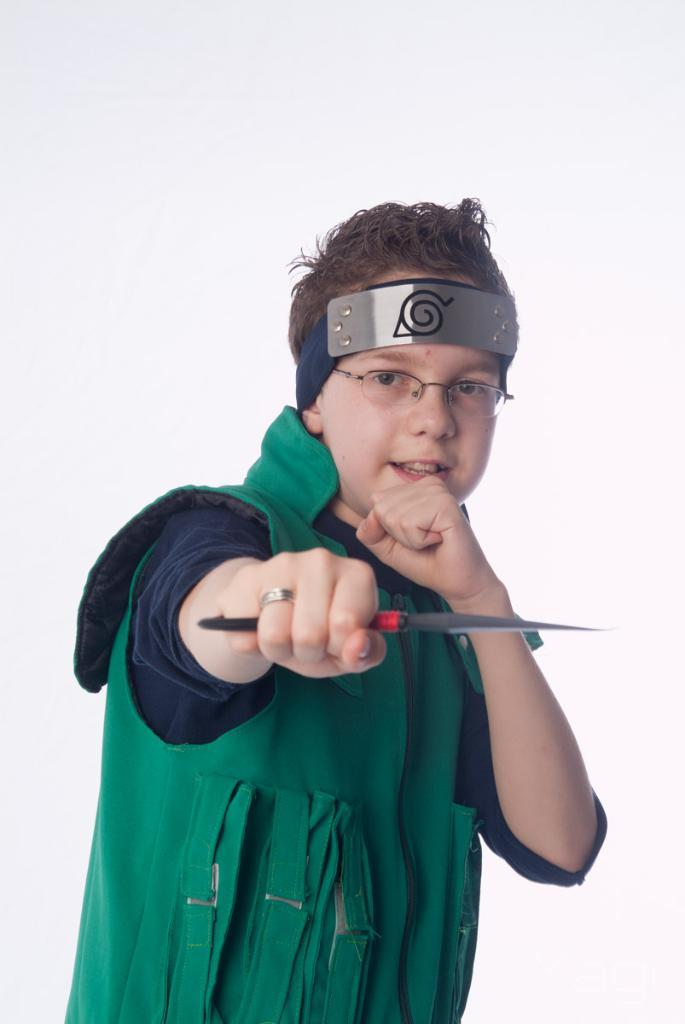Who is the main subject in the picture? There is a boy in the picture. What is the boy doing in the image? The boy is standing. What is the boy wearing on his head? The boy is wearing a costume to the head. What color is the jacket the boy is wearing? The boy is wearing a green color jacket. What object is the boy holding in the image? The boy is holding a knife. What type of curtain can be seen in the background of the image? There is no curtain visible in the image. What is the boy writing on the paper in the image? There is no paper or writing activity depicted in the image. 